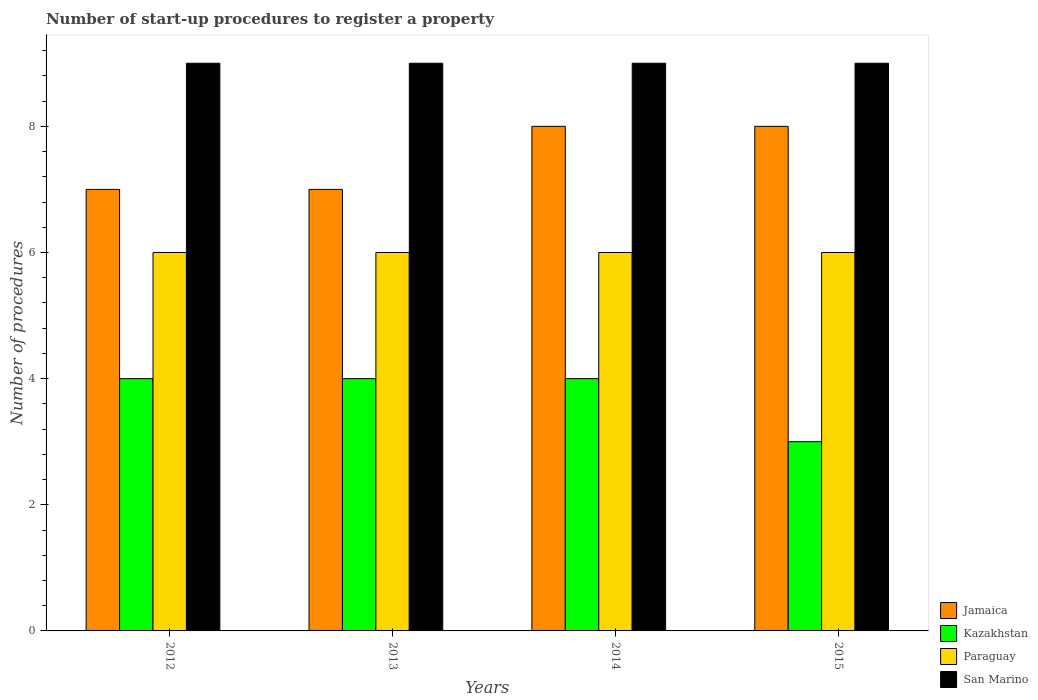How many different coloured bars are there?
Give a very brief answer. 4. Are the number of bars per tick equal to the number of legend labels?
Ensure brevity in your answer.  Yes. What is the number of procedures required to register a property in Jamaica in 2014?
Your answer should be compact. 8. Across all years, what is the maximum number of procedures required to register a property in Paraguay?
Offer a very short reply. 6. Across all years, what is the minimum number of procedures required to register a property in Kazakhstan?
Provide a succinct answer. 3. In which year was the number of procedures required to register a property in Paraguay maximum?
Your response must be concise. 2012. What is the total number of procedures required to register a property in Kazakhstan in the graph?
Keep it short and to the point. 15. What is the difference between the number of procedures required to register a property in Kazakhstan in 2014 and the number of procedures required to register a property in Paraguay in 2012?
Offer a very short reply. -2. What is the ratio of the number of procedures required to register a property in Kazakhstan in 2012 to that in 2013?
Keep it short and to the point. 1. Is the number of procedures required to register a property in San Marino in 2013 less than that in 2015?
Ensure brevity in your answer.  No. Is the sum of the number of procedures required to register a property in San Marino in 2012 and 2014 greater than the maximum number of procedures required to register a property in Kazakhstan across all years?
Your response must be concise. Yes. What does the 3rd bar from the left in 2015 represents?
Keep it short and to the point. Paraguay. What does the 2nd bar from the right in 2013 represents?
Offer a terse response. Paraguay. Is it the case that in every year, the sum of the number of procedures required to register a property in San Marino and number of procedures required to register a property in Jamaica is greater than the number of procedures required to register a property in Paraguay?
Keep it short and to the point. Yes. How many bars are there?
Offer a very short reply. 16. Are all the bars in the graph horizontal?
Give a very brief answer. No. How many years are there in the graph?
Your answer should be very brief. 4. Are the values on the major ticks of Y-axis written in scientific E-notation?
Ensure brevity in your answer.  No. Does the graph contain any zero values?
Your response must be concise. No. How many legend labels are there?
Your answer should be compact. 4. How are the legend labels stacked?
Provide a short and direct response. Vertical. What is the title of the graph?
Provide a short and direct response. Number of start-up procedures to register a property. Does "OECD members" appear as one of the legend labels in the graph?
Make the answer very short. No. What is the label or title of the X-axis?
Your answer should be compact. Years. What is the label or title of the Y-axis?
Offer a terse response. Number of procedures. What is the Number of procedures of Kazakhstan in 2012?
Your answer should be compact. 4. What is the Number of procedures in Paraguay in 2012?
Keep it short and to the point. 6. What is the Number of procedures of San Marino in 2012?
Provide a short and direct response. 9. What is the Number of procedures in Jamaica in 2013?
Your answer should be compact. 7. What is the Number of procedures in Kazakhstan in 2013?
Make the answer very short. 4. What is the Number of procedures in San Marino in 2013?
Provide a short and direct response. 9. What is the Number of procedures in Kazakhstan in 2014?
Your response must be concise. 4. What is the Number of procedures in San Marino in 2014?
Keep it short and to the point. 9. What is the Number of procedures in San Marino in 2015?
Provide a succinct answer. 9. Across all years, what is the maximum Number of procedures in Jamaica?
Your answer should be very brief. 8. Across all years, what is the maximum Number of procedures of Paraguay?
Provide a succinct answer. 6. Across all years, what is the maximum Number of procedures in San Marino?
Give a very brief answer. 9. Across all years, what is the minimum Number of procedures of San Marino?
Make the answer very short. 9. What is the difference between the Number of procedures in Jamaica in 2012 and that in 2013?
Provide a short and direct response. 0. What is the difference between the Number of procedures of Kazakhstan in 2012 and that in 2013?
Give a very brief answer. 0. What is the difference between the Number of procedures in Paraguay in 2012 and that in 2013?
Your answer should be compact. 0. What is the difference between the Number of procedures in San Marino in 2012 and that in 2013?
Provide a short and direct response. 0. What is the difference between the Number of procedures of Jamaica in 2012 and that in 2014?
Your response must be concise. -1. What is the difference between the Number of procedures in Kazakhstan in 2012 and that in 2014?
Make the answer very short. 0. What is the difference between the Number of procedures of Paraguay in 2012 and that in 2014?
Offer a very short reply. 0. What is the difference between the Number of procedures of Jamaica in 2012 and that in 2015?
Your answer should be very brief. -1. What is the difference between the Number of procedures of Kazakhstan in 2012 and that in 2015?
Your answer should be compact. 1. What is the difference between the Number of procedures in Paraguay in 2012 and that in 2015?
Provide a short and direct response. 0. What is the difference between the Number of procedures in Jamaica in 2013 and that in 2014?
Your response must be concise. -1. What is the difference between the Number of procedures of Paraguay in 2013 and that in 2014?
Make the answer very short. 0. What is the difference between the Number of procedures in San Marino in 2013 and that in 2014?
Provide a succinct answer. 0. What is the difference between the Number of procedures in Jamaica in 2013 and that in 2015?
Offer a very short reply. -1. What is the difference between the Number of procedures of San Marino in 2014 and that in 2015?
Provide a short and direct response. 0. What is the difference between the Number of procedures in Jamaica in 2012 and the Number of procedures in Kazakhstan in 2013?
Provide a succinct answer. 3. What is the difference between the Number of procedures in Jamaica in 2012 and the Number of procedures in Paraguay in 2013?
Your answer should be compact. 1. What is the difference between the Number of procedures of Kazakhstan in 2012 and the Number of procedures of Paraguay in 2013?
Provide a succinct answer. -2. What is the difference between the Number of procedures in Paraguay in 2012 and the Number of procedures in San Marino in 2013?
Your answer should be very brief. -3. What is the difference between the Number of procedures in Jamaica in 2012 and the Number of procedures in San Marino in 2014?
Offer a terse response. -2. What is the difference between the Number of procedures of Kazakhstan in 2012 and the Number of procedures of Paraguay in 2014?
Offer a terse response. -2. What is the difference between the Number of procedures in Jamaica in 2012 and the Number of procedures in Paraguay in 2015?
Make the answer very short. 1. What is the difference between the Number of procedures of Kazakhstan in 2012 and the Number of procedures of San Marino in 2015?
Your response must be concise. -5. What is the difference between the Number of procedures of Jamaica in 2013 and the Number of procedures of Paraguay in 2014?
Offer a terse response. 1. What is the difference between the Number of procedures in Kazakhstan in 2013 and the Number of procedures in Paraguay in 2015?
Offer a very short reply. -2. What is the difference between the Number of procedures in Kazakhstan in 2013 and the Number of procedures in San Marino in 2015?
Give a very brief answer. -5. What is the difference between the Number of procedures of Paraguay in 2013 and the Number of procedures of San Marino in 2015?
Give a very brief answer. -3. What is the difference between the Number of procedures of Jamaica in 2014 and the Number of procedures of Kazakhstan in 2015?
Keep it short and to the point. 5. What is the difference between the Number of procedures of Jamaica in 2014 and the Number of procedures of Paraguay in 2015?
Keep it short and to the point. 2. What is the difference between the Number of procedures in Jamaica in 2014 and the Number of procedures in San Marino in 2015?
Offer a terse response. -1. What is the difference between the Number of procedures in Kazakhstan in 2014 and the Number of procedures in Paraguay in 2015?
Keep it short and to the point. -2. What is the difference between the Number of procedures of Paraguay in 2014 and the Number of procedures of San Marino in 2015?
Offer a very short reply. -3. What is the average Number of procedures in Jamaica per year?
Keep it short and to the point. 7.5. What is the average Number of procedures of Kazakhstan per year?
Give a very brief answer. 3.75. What is the average Number of procedures in Paraguay per year?
Make the answer very short. 6. In the year 2012, what is the difference between the Number of procedures of Jamaica and Number of procedures of Kazakhstan?
Make the answer very short. 3. In the year 2012, what is the difference between the Number of procedures in Jamaica and Number of procedures in San Marino?
Offer a very short reply. -2. In the year 2012, what is the difference between the Number of procedures of Kazakhstan and Number of procedures of Paraguay?
Provide a succinct answer. -2. In the year 2012, what is the difference between the Number of procedures in Kazakhstan and Number of procedures in San Marino?
Your response must be concise. -5. In the year 2013, what is the difference between the Number of procedures in Jamaica and Number of procedures in Paraguay?
Ensure brevity in your answer.  1. In the year 2013, what is the difference between the Number of procedures of Kazakhstan and Number of procedures of Paraguay?
Give a very brief answer. -2. In the year 2013, what is the difference between the Number of procedures in Paraguay and Number of procedures in San Marino?
Offer a very short reply. -3. In the year 2014, what is the difference between the Number of procedures of Jamaica and Number of procedures of San Marino?
Offer a terse response. -1. In the year 2014, what is the difference between the Number of procedures in Paraguay and Number of procedures in San Marino?
Provide a succinct answer. -3. In the year 2015, what is the difference between the Number of procedures of Jamaica and Number of procedures of San Marino?
Your answer should be very brief. -1. In the year 2015, what is the difference between the Number of procedures in Paraguay and Number of procedures in San Marino?
Make the answer very short. -3. What is the ratio of the Number of procedures in Jamaica in 2012 to that in 2013?
Provide a succinct answer. 1. What is the ratio of the Number of procedures of Paraguay in 2012 to that in 2013?
Your answer should be very brief. 1. What is the ratio of the Number of procedures in Jamaica in 2012 to that in 2014?
Give a very brief answer. 0.88. What is the ratio of the Number of procedures in Kazakhstan in 2012 to that in 2014?
Your response must be concise. 1. What is the ratio of the Number of procedures in San Marino in 2012 to that in 2014?
Provide a succinct answer. 1. What is the ratio of the Number of procedures in Kazakhstan in 2012 to that in 2015?
Your response must be concise. 1.33. What is the ratio of the Number of procedures in San Marino in 2012 to that in 2015?
Offer a very short reply. 1. What is the ratio of the Number of procedures of Jamaica in 2013 to that in 2014?
Your answer should be very brief. 0.88. What is the ratio of the Number of procedures in Kazakhstan in 2013 to that in 2014?
Your answer should be compact. 1. What is the ratio of the Number of procedures of San Marino in 2013 to that in 2014?
Provide a succinct answer. 1. What is the ratio of the Number of procedures in Paraguay in 2013 to that in 2015?
Make the answer very short. 1. What is the ratio of the Number of procedures of Jamaica in 2014 to that in 2015?
Offer a very short reply. 1. What is the difference between the highest and the second highest Number of procedures in Kazakhstan?
Your response must be concise. 0. What is the difference between the highest and the lowest Number of procedures in Jamaica?
Your answer should be very brief. 1. What is the difference between the highest and the lowest Number of procedures in Kazakhstan?
Provide a succinct answer. 1. 